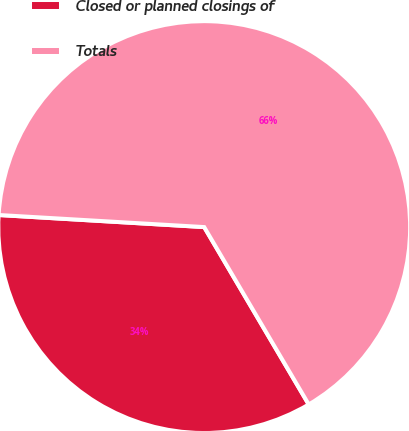Convert chart to OTSL. <chart><loc_0><loc_0><loc_500><loc_500><pie_chart><fcel>Closed or planned closings of<fcel>Totals<nl><fcel>34.41%<fcel>65.59%<nl></chart> 